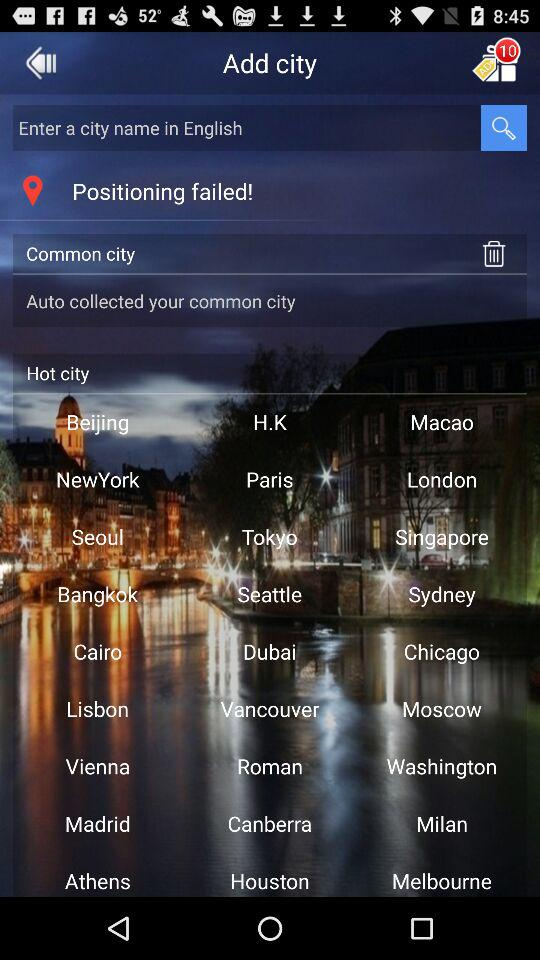How many new notifications are there? There are 10 new notifications. 